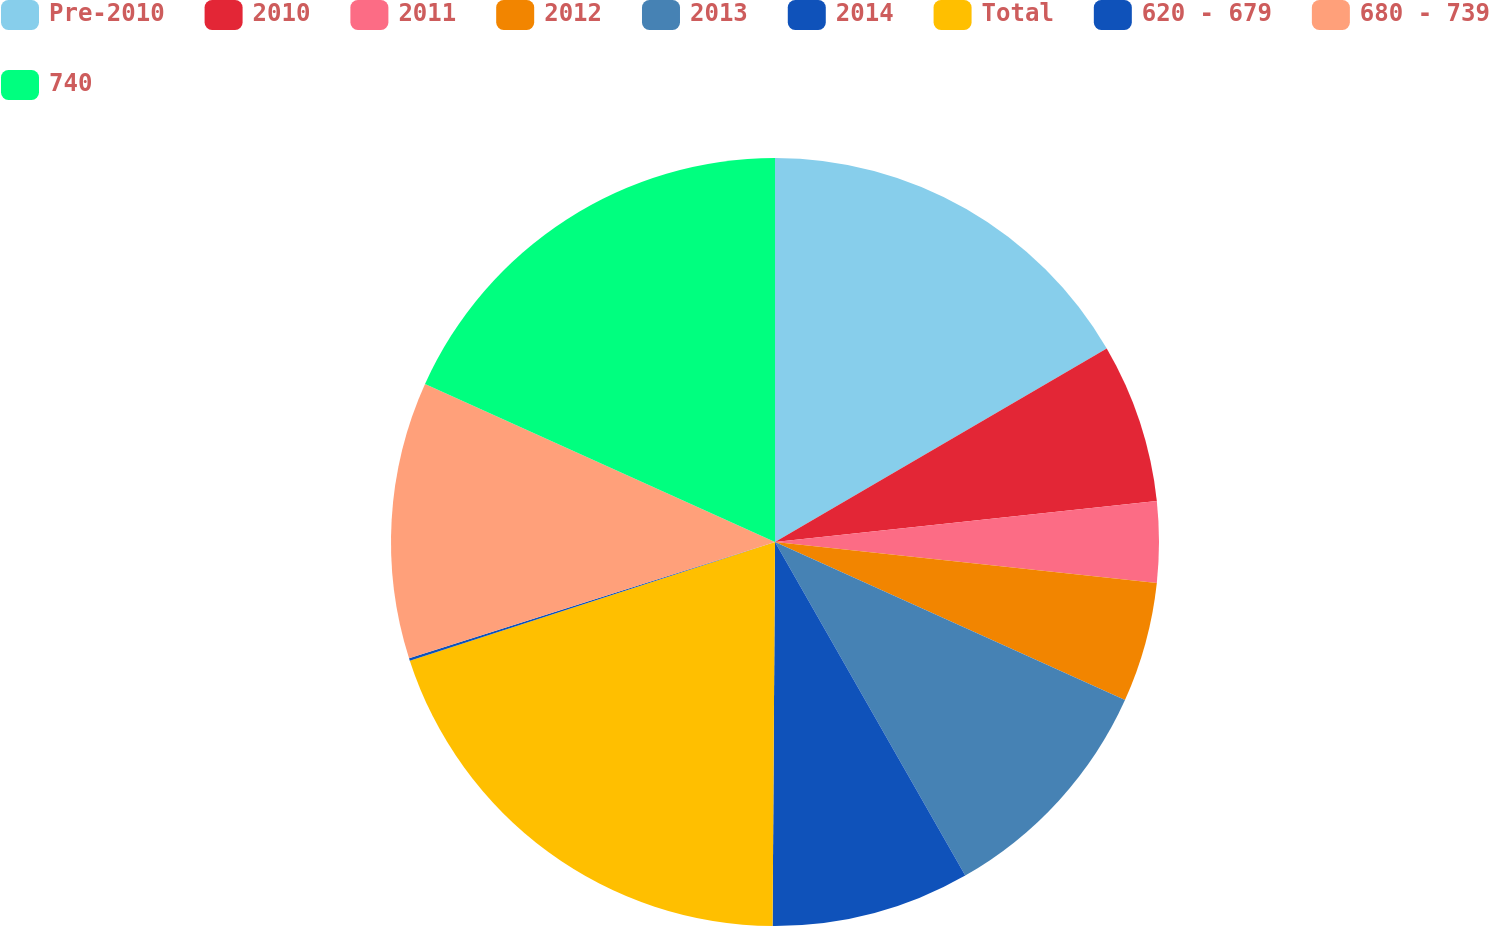Convert chart to OTSL. <chart><loc_0><loc_0><loc_500><loc_500><pie_chart><fcel>Pre-2010<fcel>2010<fcel>2011<fcel>2012<fcel>2013<fcel>2014<fcel>Total<fcel>620 - 679<fcel>680 - 739<fcel>740<nl><fcel>16.6%<fcel>6.7%<fcel>3.4%<fcel>5.05%<fcel>10.0%<fcel>8.35%<fcel>19.9%<fcel>0.1%<fcel>11.65%<fcel>18.25%<nl></chart> 